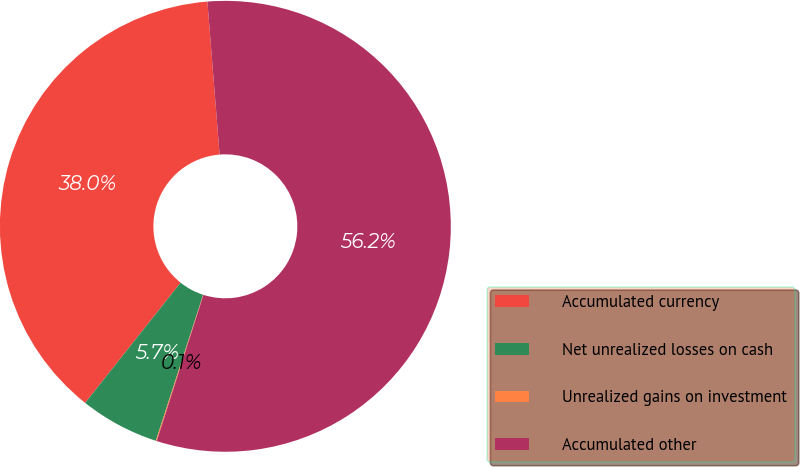<chart> <loc_0><loc_0><loc_500><loc_500><pie_chart><fcel>Accumulated currency<fcel>Net unrealized losses on cash<fcel>Unrealized gains on investment<fcel>Accumulated other<nl><fcel>38.05%<fcel>5.69%<fcel>0.07%<fcel>56.19%<nl></chart> 